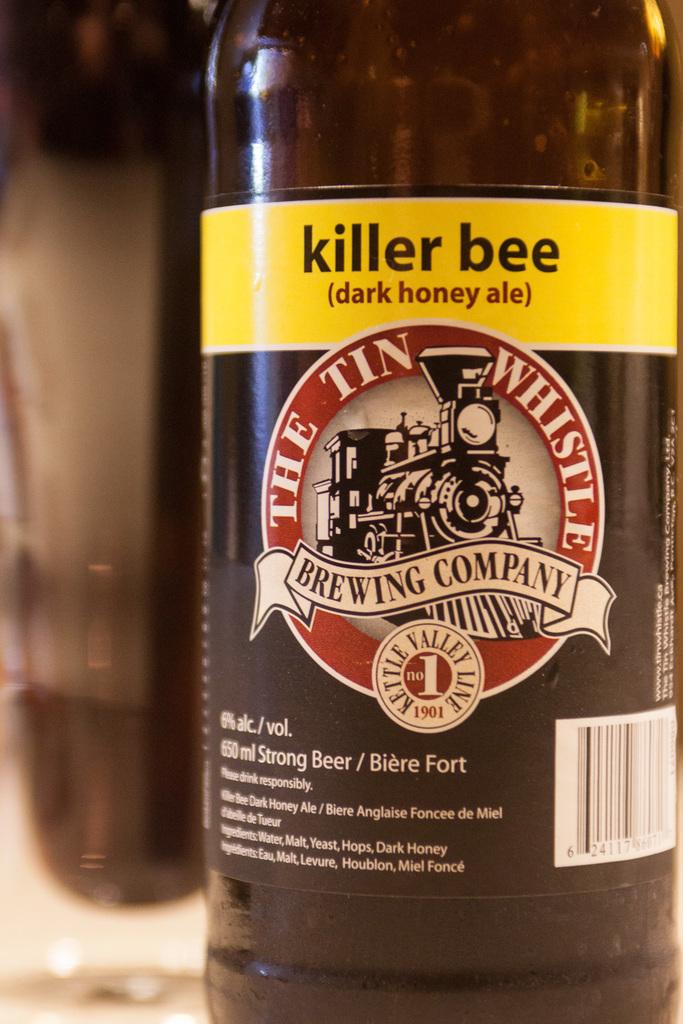What percentage alcohol is it/?
Your answer should be very brief. 6%. 